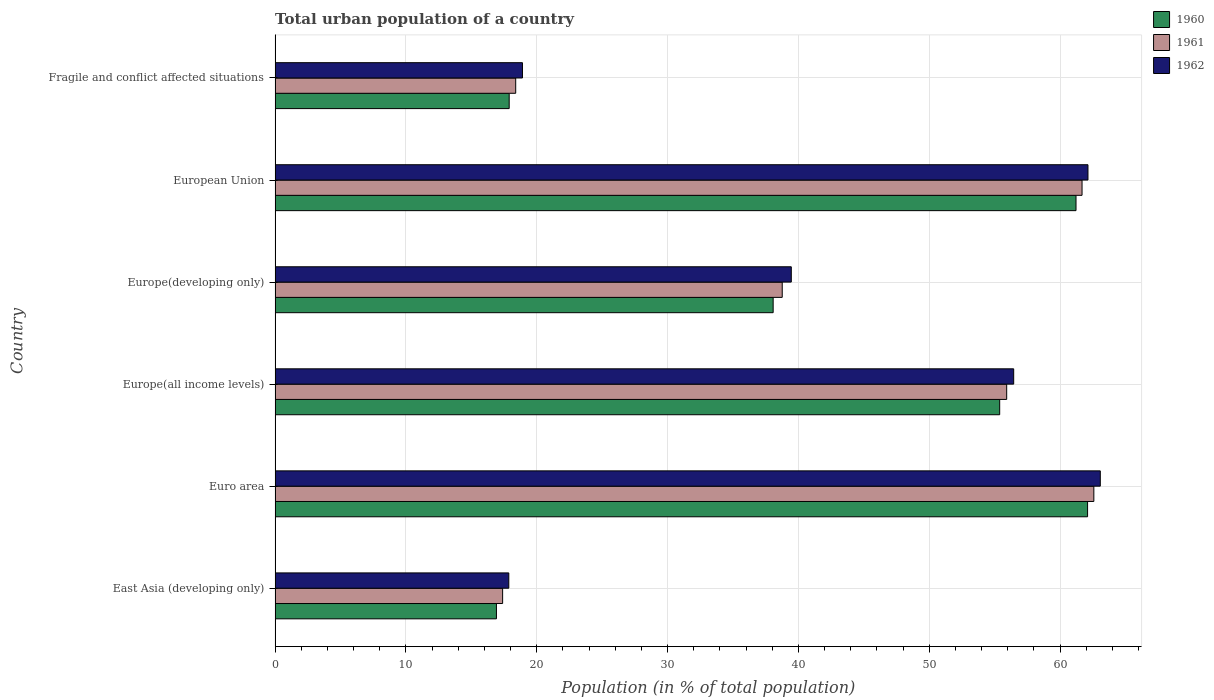How many different coloured bars are there?
Your response must be concise. 3. How many groups of bars are there?
Offer a terse response. 6. Are the number of bars on each tick of the Y-axis equal?
Your answer should be very brief. Yes. How many bars are there on the 5th tick from the top?
Offer a very short reply. 3. How many bars are there on the 5th tick from the bottom?
Your response must be concise. 3. In how many cases, is the number of bars for a given country not equal to the number of legend labels?
Offer a terse response. 0. What is the urban population in 1961 in Fragile and conflict affected situations?
Your response must be concise. 18.39. Across all countries, what is the maximum urban population in 1961?
Your answer should be compact. 62.58. Across all countries, what is the minimum urban population in 1962?
Provide a short and direct response. 17.86. In which country was the urban population in 1960 maximum?
Provide a succinct answer. Euro area. In which country was the urban population in 1960 minimum?
Give a very brief answer. East Asia (developing only). What is the total urban population in 1962 in the graph?
Your answer should be compact. 257.87. What is the difference between the urban population in 1961 in East Asia (developing only) and that in European Union?
Your answer should be very brief. -44.28. What is the difference between the urban population in 1960 in Euro area and the urban population in 1962 in European Union?
Ensure brevity in your answer.  -0.03. What is the average urban population in 1962 per country?
Your response must be concise. 42.98. What is the difference between the urban population in 1961 and urban population in 1960 in Europe(all income levels)?
Provide a succinct answer. 0.54. What is the ratio of the urban population in 1960 in Europe(all income levels) to that in Fragile and conflict affected situations?
Provide a short and direct response. 3.1. Is the urban population in 1962 in Europe(all income levels) less than that in Fragile and conflict affected situations?
Your answer should be very brief. No. What is the difference between the highest and the second highest urban population in 1960?
Offer a very short reply. 0.88. What is the difference between the highest and the lowest urban population in 1962?
Ensure brevity in your answer.  45.21. What does the 3rd bar from the top in Europe(all income levels) represents?
Offer a terse response. 1960. Is it the case that in every country, the sum of the urban population in 1962 and urban population in 1960 is greater than the urban population in 1961?
Your answer should be compact. Yes. Are all the bars in the graph horizontal?
Provide a short and direct response. Yes. How many countries are there in the graph?
Keep it short and to the point. 6. Does the graph contain grids?
Provide a short and direct response. Yes. Where does the legend appear in the graph?
Your answer should be very brief. Top right. How many legend labels are there?
Your answer should be compact. 3. How are the legend labels stacked?
Your answer should be compact. Vertical. What is the title of the graph?
Make the answer very short. Total urban population of a country. What is the label or title of the X-axis?
Your answer should be very brief. Population (in % of total population). What is the label or title of the Y-axis?
Offer a terse response. Country. What is the Population (in % of total population) of 1960 in East Asia (developing only)?
Your answer should be very brief. 16.92. What is the Population (in % of total population) of 1961 in East Asia (developing only)?
Your answer should be very brief. 17.39. What is the Population (in % of total population) in 1962 in East Asia (developing only)?
Your answer should be compact. 17.86. What is the Population (in % of total population) of 1960 in Euro area?
Provide a short and direct response. 62.1. What is the Population (in % of total population) of 1961 in Euro area?
Ensure brevity in your answer.  62.58. What is the Population (in % of total population) of 1962 in Euro area?
Offer a very short reply. 63.07. What is the Population (in % of total population) in 1960 in Europe(all income levels)?
Ensure brevity in your answer.  55.38. What is the Population (in % of total population) in 1961 in Europe(all income levels)?
Your response must be concise. 55.92. What is the Population (in % of total population) of 1962 in Europe(all income levels)?
Your answer should be compact. 56.45. What is the Population (in % of total population) of 1960 in Europe(developing only)?
Your response must be concise. 38.07. What is the Population (in % of total population) of 1961 in Europe(developing only)?
Make the answer very short. 38.76. What is the Population (in % of total population) of 1962 in Europe(developing only)?
Keep it short and to the point. 39.45. What is the Population (in % of total population) of 1960 in European Union?
Your response must be concise. 61.21. What is the Population (in % of total population) in 1961 in European Union?
Offer a terse response. 61.67. What is the Population (in % of total population) of 1962 in European Union?
Ensure brevity in your answer.  62.13. What is the Population (in % of total population) of 1960 in Fragile and conflict affected situations?
Your response must be concise. 17.89. What is the Population (in % of total population) of 1961 in Fragile and conflict affected situations?
Keep it short and to the point. 18.39. What is the Population (in % of total population) of 1962 in Fragile and conflict affected situations?
Your response must be concise. 18.91. Across all countries, what is the maximum Population (in % of total population) in 1960?
Your answer should be compact. 62.1. Across all countries, what is the maximum Population (in % of total population) in 1961?
Provide a succinct answer. 62.58. Across all countries, what is the maximum Population (in % of total population) in 1962?
Offer a terse response. 63.07. Across all countries, what is the minimum Population (in % of total population) of 1960?
Make the answer very short. 16.92. Across all countries, what is the minimum Population (in % of total population) in 1961?
Your answer should be very brief. 17.39. Across all countries, what is the minimum Population (in % of total population) of 1962?
Provide a short and direct response. 17.86. What is the total Population (in % of total population) in 1960 in the graph?
Make the answer very short. 251.56. What is the total Population (in % of total population) in 1961 in the graph?
Make the answer very short. 254.7. What is the total Population (in % of total population) of 1962 in the graph?
Your response must be concise. 257.87. What is the difference between the Population (in % of total population) in 1960 in East Asia (developing only) and that in Euro area?
Give a very brief answer. -45.18. What is the difference between the Population (in % of total population) in 1961 in East Asia (developing only) and that in Euro area?
Your answer should be very brief. -45.18. What is the difference between the Population (in % of total population) in 1962 in East Asia (developing only) and that in Euro area?
Offer a very short reply. -45.21. What is the difference between the Population (in % of total population) in 1960 in East Asia (developing only) and that in Europe(all income levels)?
Offer a very short reply. -38.46. What is the difference between the Population (in % of total population) in 1961 in East Asia (developing only) and that in Europe(all income levels)?
Your answer should be very brief. -38.52. What is the difference between the Population (in % of total population) in 1962 in East Asia (developing only) and that in Europe(all income levels)?
Your response must be concise. -38.59. What is the difference between the Population (in % of total population) in 1960 in East Asia (developing only) and that in Europe(developing only)?
Offer a very short reply. -21.15. What is the difference between the Population (in % of total population) of 1961 in East Asia (developing only) and that in Europe(developing only)?
Provide a short and direct response. -21.37. What is the difference between the Population (in % of total population) of 1962 in East Asia (developing only) and that in Europe(developing only)?
Keep it short and to the point. -21.59. What is the difference between the Population (in % of total population) in 1960 in East Asia (developing only) and that in European Union?
Provide a succinct answer. -44.3. What is the difference between the Population (in % of total population) of 1961 in East Asia (developing only) and that in European Union?
Offer a very short reply. -44.28. What is the difference between the Population (in % of total population) in 1962 in East Asia (developing only) and that in European Union?
Your answer should be very brief. -44.26. What is the difference between the Population (in % of total population) in 1960 in East Asia (developing only) and that in Fragile and conflict affected situations?
Keep it short and to the point. -0.97. What is the difference between the Population (in % of total population) of 1961 in East Asia (developing only) and that in Fragile and conflict affected situations?
Ensure brevity in your answer.  -1. What is the difference between the Population (in % of total population) of 1962 in East Asia (developing only) and that in Fragile and conflict affected situations?
Your answer should be very brief. -1.04. What is the difference between the Population (in % of total population) in 1960 in Euro area and that in Europe(all income levels)?
Give a very brief answer. 6.72. What is the difference between the Population (in % of total population) in 1961 in Euro area and that in Europe(all income levels)?
Your answer should be compact. 6.66. What is the difference between the Population (in % of total population) of 1962 in Euro area and that in Europe(all income levels)?
Offer a terse response. 6.62. What is the difference between the Population (in % of total population) in 1960 in Euro area and that in Europe(developing only)?
Your response must be concise. 24.03. What is the difference between the Population (in % of total population) of 1961 in Euro area and that in Europe(developing only)?
Provide a succinct answer. 23.82. What is the difference between the Population (in % of total population) in 1962 in Euro area and that in Europe(developing only)?
Offer a very short reply. 23.62. What is the difference between the Population (in % of total population) in 1960 in Euro area and that in European Union?
Ensure brevity in your answer.  0.88. What is the difference between the Population (in % of total population) of 1961 in Euro area and that in European Union?
Provide a short and direct response. 0.9. What is the difference between the Population (in % of total population) of 1962 in Euro area and that in European Union?
Ensure brevity in your answer.  0.94. What is the difference between the Population (in % of total population) of 1960 in Euro area and that in Fragile and conflict affected situations?
Provide a short and direct response. 44.2. What is the difference between the Population (in % of total population) in 1961 in Euro area and that in Fragile and conflict affected situations?
Your answer should be very brief. 44.19. What is the difference between the Population (in % of total population) of 1962 in Euro area and that in Fragile and conflict affected situations?
Give a very brief answer. 44.16. What is the difference between the Population (in % of total population) of 1960 in Europe(all income levels) and that in Europe(developing only)?
Your answer should be compact. 17.31. What is the difference between the Population (in % of total population) of 1961 in Europe(all income levels) and that in Europe(developing only)?
Your response must be concise. 17.16. What is the difference between the Population (in % of total population) in 1962 in Europe(all income levels) and that in Europe(developing only)?
Your answer should be very brief. 17. What is the difference between the Population (in % of total population) of 1960 in Europe(all income levels) and that in European Union?
Your response must be concise. -5.83. What is the difference between the Population (in % of total population) in 1961 in Europe(all income levels) and that in European Union?
Offer a very short reply. -5.76. What is the difference between the Population (in % of total population) of 1962 in Europe(all income levels) and that in European Union?
Provide a succinct answer. -5.68. What is the difference between the Population (in % of total population) of 1960 in Europe(all income levels) and that in Fragile and conflict affected situations?
Give a very brief answer. 37.49. What is the difference between the Population (in % of total population) in 1961 in Europe(all income levels) and that in Fragile and conflict affected situations?
Your response must be concise. 37.53. What is the difference between the Population (in % of total population) in 1962 in Europe(all income levels) and that in Fragile and conflict affected situations?
Offer a very short reply. 37.54. What is the difference between the Population (in % of total population) of 1960 in Europe(developing only) and that in European Union?
Your answer should be very brief. -23.15. What is the difference between the Population (in % of total population) of 1961 in Europe(developing only) and that in European Union?
Your answer should be very brief. -22.91. What is the difference between the Population (in % of total population) of 1962 in Europe(developing only) and that in European Union?
Make the answer very short. -22.67. What is the difference between the Population (in % of total population) of 1960 in Europe(developing only) and that in Fragile and conflict affected situations?
Your answer should be very brief. 20.17. What is the difference between the Population (in % of total population) of 1961 in Europe(developing only) and that in Fragile and conflict affected situations?
Give a very brief answer. 20.37. What is the difference between the Population (in % of total population) in 1962 in Europe(developing only) and that in Fragile and conflict affected situations?
Offer a terse response. 20.55. What is the difference between the Population (in % of total population) of 1960 in European Union and that in Fragile and conflict affected situations?
Offer a very short reply. 43.32. What is the difference between the Population (in % of total population) in 1961 in European Union and that in Fragile and conflict affected situations?
Your answer should be very brief. 43.28. What is the difference between the Population (in % of total population) of 1962 in European Union and that in Fragile and conflict affected situations?
Provide a short and direct response. 43.22. What is the difference between the Population (in % of total population) of 1960 in East Asia (developing only) and the Population (in % of total population) of 1961 in Euro area?
Offer a terse response. -45.66. What is the difference between the Population (in % of total population) of 1960 in East Asia (developing only) and the Population (in % of total population) of 1962 in Euro area?
Keep it short and to the point. -46.15. What is the difference between the Population (in % of total population) in 1961 in East Asia (developing only) and the Population (in % of total population) in 1962 in Euro area?
Your answer should be compact. -45.68. What is the difference between the Population (in % of total population) in 1960 in East Asia (developing only) and the Population (in % of total population) in 1961 in Europe(all income levels)?
Make the answer very short. -39. What is the difference between the Population (in % of total population) in 1960 in East Asia (developing only) and the Population (in % of total population) in 1962 in Europe(all income levels)?
Your answer should be compact. -39.53. What is the difference between the Population (in % of total population) in 1961 in East Asia (developing only) and the Population (in % of total population) in 1962 in Europe(all income levels)?
Offer a terse response. -39.06. What is the difference between the Population (in % of total population) of 1960 in East Asia (developing only) and the Population (in % of total population) of 1961 in Europe(developing only)?
Offer a terse response. -21.84. What is the difference between the Population (in % of total population) of 1960 in East Asia (developing only) and the Population (in % of total population) of 1962 in Europe(developing only)?
Your answer should be compact. -22.54. What is the difference between the Population (in % of total population) in 1961 in East Asia (developing only) and the Population (in % of total population) in 1962 in Europe(developing only)?
Make the answer very short. -22.06. What is the difference between the Population (in % of total population) in 1960 in East Asia (developing only) and the Population (in % of total population) in 1961 in European Union?
Offer a very short reply. -44.76. What is the difference between the Population (in % of total population) of 1960 in East Asia (developing only) and the Population (in % of total population) of 1962 in European Union?
Provide a succinct answer. -45.21. What is the difference between the Population (in % of total population) of 1961 in East Asia (developing only) and the Population (in % of total population) of 1962 in European Union?
Make the answer very short. -44.74. What is the difference between the Population (in % of total population) of 1960 in East Asia (developing only) and the Population (in % of total population) of 1961 in Fragile and conflict affected situations?
Provide a short and direct response. -1.47. What is the difference between the Population (in % of total population) of 1960 in East Asia (developing only) and the Population (in % of total population) of 1962 in Fragile and conflict affected situations?
Offer a terse response. -1.99. What is the difference between the Population (in % of total population) in 1961 in East Asia (developing only) and the Population (in % of total population) in 1962 in Fragile and conflict affected situations?
Provide a succinct answer. -1.52. What is the difference between the Population (in % of total population) of 1960 in Euro area and the Population (in % of total population) of 1961 in Europe(all income levels)?
Make the answer very short. 6.18. What is the difference between the Population (in % of total population) in 1960 in Euro area and the Population (in % of total population) in 1962 in Europe(all income levels)?
Your response must be concise. 5.65. What is the difference between the Population (in % of total population) in 1961 in Euro area and the Population (in % of total population) in 1962 in Europe(all income levels)?
Ensure brevity in your answer.  6.13. What is the difference between the Population (in % of total population) in 1960 in Euro area and the Population (in % of total population) in 1961 in Europe(developing only)?
Your answer should be very brief. 23.34. What is the difference between the Population (in % of total population) in 1960 in Euro area and the Population (in % of total population) in 1962 in Europe(developing only)?
Ensure brevity in your answer.  22.64. What is the difference between the Population (in % of total population) of 1961 in Euro area and the Population (in % of total population) of 1962 in Europe(developing only)?
Give a very brief answer. 23.12. What is the difference between the Population (in % of total population) in 1960 in Euro area and the Population (in % of total population) in 1961 in European Union?
Make the answer very short. 0.42. What is the difference between the Population (in % of total population) in 1960 in Euro area and the Population (in % of total population) in 1962 in European Union?
Your response must be concise. -0.03. What is the difference between the Population (in % of total population) of 1961 in Euro area and the Population (in % of total population) of 1962 in European Union?
Your answer should be very brief. 0.45. What is the difference between the Population (in % of total population) in 1960 in Euro area and the Population (in % of total population) in 1961 in Fragile and conflict affected situations?
Make the answer very short. 43.71. What is the difference between the Population (in % of total population) of 1960 in Euro area and the Population (in % of total population) of 1962 in Fragile and conflict affected situations?
Your answer should be very brief. 43.19. What is the difference between the Population (in % of total population) in 1961 in Euro area and the Population (in % of total population) in 1962 in Fragile and conflict affected situations?
Your answer should be very brief. 43.67. What is the difference between the Population (in % of total population) in 1960 in Europe(all income levels) and the Population (in % of total population) in 1961 in Europe(developing only)?
Ensure brevity in your answer.  16.62. What is the difference between the Population (in % of total population) of 1960 in Europe(all income levels) and the Population (in % of total population) of 1962 in Europe(developing only)?
Ensure brevity in your answer.  15.93. What is the difference between the Population (in % of total population) of 1961 in Europe(all income levels) and the Population (in % of total population) of 1962 in Europe(developing only)?
Ensure brevity in your answer.  16.46. What is the difference between the Population (in % of total population) in 1960 in Europe(all income levels) and the Population (in % of total population) in 1961 in European Union?
Give a very brief answer. -6.29. What is the difference between the Population (in % of total population) in 1960 in Europe(all income levels) and the Population (in % of total population) in 1962 in European Union?
Provide a short and direct response. -6.75. What is the difference between the Population (in % of total population) of 1961 in Europe(all income levels) and the Population (in % of total population) of 1962 in European Union?
Ensure brevity in your answer.  -6.21. What is the difference between the Population (in % of total population) in 1960 in Europe(all income levels) and the Population (in % of total population) in 1961 in Fragile and conflict affected situations?
Make the answer very short. 36.99. What is the difference between the Population (in % of total population) of 1960 in Europe(all income levels) and the Population (in % of total population) of 1962 in Fragile and conflict affected situations?
Your answer should be compact. 36.47. What is the difference between the Population (in % of total population) in 1961 in Europe(all income levels) and the Population (in % of total population) in 1962 in Fragile and conflict affected situations?
Make the answer very short. 37.01. What is the difference between the Population (in % of total population) in 1960 in Europe(developing only) and the Population (in % of total population) in 1961 in European Union?
Make the answer very short. -23.61. What is the difference between the Population (in % of total population) of 1960 in Europe(developing only) and the Population (in % of total population) of 1962 in European Union?
Give a very brief answer. -24.06. What is the difference between the Population (in % of total population) of 1961 in Europe(developing only) and the Population (in % of total population) of 1962 in European Union?
Provide a succinct answer. -23.37. What is the difference between the Population (in % of total population) in 1960 in Europe(developing only) and the Population (in % of total population) in 1961 in Fragile and conflict affected situations?
Give a very brief answer. 19.68. What is the difference between the Population (in % of total population) of 1960 in Europe(developing only) and the Population (in % of total population) of 1962 in Fragile and conflict affected situations?
Make the answer very short. 19.16. What is the difference between the Population (in % of total population) in 1961 in Europe(developing only) and the Population (in % of total population) in 1962 in Fragile and conflict affected situations?
Provide a succinct answer. 19.85. What is the difference between the Population (in % of total population) in 1960 in European Union and the Population (in % of total population) in 1961 in Fragile and conflict affected situations?
Offer a terse response. 42.82. What is the difference between the Population (in % of total population) of 1960 in European Union and the Population (in % of total population) of 1962 in Fragile and conflict affected situations?
Provide a succinct answer. 42.31. What is the difference between the Population (in % of total population) in 1961 in European Union and the Population (in % of total population) in 1962 in Fragile and conflict affected situations?
Give a very brief answer. 42.77. What is the average Population (in % of total population) in 1960 per country?
Provide a short and direct response. 41.93. What is the average Population (in % of total population) of 1961 per country?
Keep it short and to the point. 42.45. What is the average Population (in % of total population) in 1962 per country?
Your answer should be very brief. 42.98. What is the difference between the Population (in % of total population) in 1960 and Population (in % of total population) in 1961 in East Asia (developing only)?
Your answer should be very brief. -0.47. What is the difference between the Population (in % of total population) of 1960 and Population (in % of total population) of 1962 in East Asia (developing only)?
Your answer should be compact. -0.95. What is the difference between the Population (in % of total population) of 1961 and Population (in % of total population) of 1962 in East Asia (developing only)?
Your answer should be compact. -0.47. What is the difference between the Population (in % of total population) in 1960 and Population (in % of total population) in 1961 in Euro area?
Provide a succinct answer. -0.48. What is the difference between the Population (in % of total population) of 1960 and Population (in % of total population) of 1962 in Euro area?
Your answer should be compact. -0.97. What is the difference between the Population (in % of total population) in 1961 and Population (in % of total population) in 1962 in Euro area?
Your response must be concise. -0.49. What is the difference between the Population (in % of total population) in 1960 and Population (in % of total population) in 1961 in Europe(all income levels)?
Offer a terse response. -0.54. What is the difference between the Population (in % of total population) in 1960 and Population (in % of total population) in 1962 in Europe(all income levels)?
Ensure brevity in your answer.  -1.07. What is the difference between the Population (in % of total population) of 1961 and Population (in % of total population) of 1962 in Europe(all income levels)?
Ensure brevity in your answer.  -0.53. What is the difference between the Population (in % of total population) in 1960 and Population (in % of total population) in 1961 in Europe(developing only)?
Provide a short and direct response. -0.69. What is the difference between the Population (in % of total population) of 1960 and Population (in % of total population) of 1962 in Europe(developing only)?
Give a very brief answer. -1.39. What is the difference between the Population (in % of total population) of 1961 and Population (in % of total population) of 1962 in Europe(developing only)?
Offer a terse response. -0.69. What is the difference between the Population (in % of total population) in 1960 and Population (in % of total population) in 1961 in European Union?
Your answer should be very brief. -0.46. What is the difference between the Population (in % of total population) in 1960 and Population (in % of total population) in 1962 in European Union?
Your answer should be compact. -0.91. What is the difference between the Population (in % of total population) in 1961 and Population (in % of total population) in 1962 in European Union?
Provide a succinct answer. -0.45. What is the difference between the Population (in % of total population) in 1960 and Population (in % of total population) in 1961 in Fragile and conflict affected situations?
Offer a terse response. -0.5. What is the difference between the Population (in % of total population) of 1960 and Population (in % of total population) of 1962 in Fragile and conflict affected situations?
Offer a very short reply. -1.02. What is the difference between the Population (in % of total population) of 1961 and Population (in % of total population) of 1962 in Fragile and conflict affected situations?
Your response must be concise. -0.52. What is the ratio of the Population (in % of total population) of 1960 in East Asia (developing only) to that in Euro area?
Provide a succinct answer. 0.27. What is the ratio of the Population (in % of total population) in 1961 in East Asia (developing only) to that in Euro area?
Keep it short and to the point. 0.28. What is the ratio of the Population (in % of total population) of 1962 in East Asia (developing only) to that in Euro area?
Make the answer very short. 0.28. What is the ratio of the Population (in % of total population) in 1960 in East Asia (developing only) to that in Europe(all income levels)?
Offer a very short reply. 0.31. What is the ratio of the Population (in % of total population) of 1961 in East Asia (developing only) to that in Europe(all income levels)?
Your response must be concise. 0.31. What is the ratio of the Population (in % of total population) in 1962 in East Asia (developing only) to that in Europe(all income levels)?
Provide a short and direct response. 0.32. What is the ratio of the Population (in % of total population) in 1960 in East Asia (developing only) to that in Europe(developing only)?
Provide a short and direct response. 0.44. What is the ratio of the Population (in % of total population) of 1961 in East Asia (developing only) to that in Europe(developing only)?
Make the answer very short. 0.45. What is the ratio of the Population (in % of total population) in 1962 in East Asia (developing only) to that in Europe(developing only)?
Provide a succinct answer. 0.45. What is the ratio of the Population (in % of total population) in 1960 in East Asia (developing only) to that in European Union?
Offer a very short reply. 0.28. What is the ratio of the Population (in % of total population) in 1961 in East Asia (developing only) to that in European Union?
Offer a terse response. 0.28. What is the ratio of the Population (in % of total population) of 1962 in East Asia (developing only) to that in European Union?
Provide a succinct answer. 0.29. What is the ratio of the Population (in % of total population) of 1960 in East Asia (developing only) to that in Fragile and conflict affected situations?
Offer a very short reply. 0.95. What is the ratio of the Population (in % of total population) in 1961 in East Asia (developing only) to that in Fragile and conflict affected situations?
Offer a terse response. 0.95. What is the ratio of the Population (in % of total population) of 1962 in East Asia (developing only) to that in Fragile and conflict affected situations?
Your answer should be compact. 0.94. What is the ratio of the Population (in % of total population) in 1960 in Euro area to that in Europe(all income levels)?
Offer a terse response. 1.12. What is the ratio of the Population (in % of total population) of 1961 in Euro area to that in Europe(all income levels)?
Your answer should be compact. 1.12. What is the ratio of the Population (in % of total population) of 1962 in Euro area to that in Europe(all income levels)?
Your answer should be compact. 1.12. What is the ratio of the Population (in % of total population) of 1960 in Euro area to that in Europe(developing only)?
Keep it short and to the point. 1.63. What is the ratio of the Population (in % of total population) in 1961 in Euro area to that in Europe(developing only)?
Provide a succinct answer. 1.61. What is the ratio of the Population (in % of total population) of 1962 in Euro area to that in Europe(developing only)?
Your response must be concise. 1.6. What is the ratio of the Population (in % of total population) of 1960 in Euro area to that in European Union?
Your response must be concise. 1.01. What is the ratio of the Population (in % of total population) of 1961 in Euro area to that in European Union?
Your response must be concise. 1.01. What is the ratio of the Population (in % of total population) in 1962 in Euro area to that in European Union?
Keep it short and to the point. 1.02. What is the ratio of the Population (in % of total population) in 1960 in Euro area to that in Fragile and conflict affected situations?
Provide a succinct answer. 3.47. What is the ratio of the Population (in % of total population) of 1961 in Euro area to that in Fragile and conflict affected situations?
Provide a short and direct response. 3.4. What is the ratio of the Population (in % of total population) of 1962 in Euro area to that in Fragile and conflict affected situations?
Offer a very short reply. 3.34. What is the ratio of the Population (in % of total population) in 1960 in Europe(all income levels) to that in Europe(developing only)?
Provide a short and direct response. 1.45. What is the ratio of the Population (in % of total population) of 1961 in Europe(all income levels) to that in Europe(developing only)?
Make the answer very short. 1.44. What is the ratio of the Population (in % of total population) in 1962 in Europe(all income levels) to that in Europe(developing only)?
Offer a very short reply. 1.43. What is the ratio of the Population (in % of total population) of 1960 in Europe(all income levels) to that in European Union?
Your response must be concise. 0.9. What is the ratio of the Population (in % of total population) in 1961 in Europe(all income levels) to that in European Union?
Offer a terse response. 0.91. What is the ratio of the Population (in % of total population) of 1962 in Europe(all income levels) to that in European Union?
Your response must be concise. 0.91. What is the ratio of the Population (in % of total population) in 1960 in Europe(all income levels) to that in Fragile and conflict affected situations?
Make the answer very short. 3.1. What is the ratio of the Population (in % of total population) of 1961 in Europe(all income levels) to that in Fragile and conflict affected situations?
Ensure brevity in your answer.  3.04. What is the ratio of the Population (in % of total population) in 1962 in Europe(all income levels) to that in Fragile and conflict affected situations?
Provide a succinct answer. 2.99. What is the ratio of the Population (in % of total population) of 1960 in Europe(developing only) to that in European Union?
Keep it short and to the point. 0.62. What is the ratio of the Population (in % of total population) of 1961 in Europe(developing only) to that in European Union?
Make the answer very short. 0.63. What is the ratio of the Population (in % of total population) of 1962 in Europe(developing only) to that in European Union?
Offer a terse response. 0.64. What is the ratio of the Population (in % of total population) of 1960 in Europe(developing only) to that in Fragile and conflict affected situations?
Ensure brevity in your answer.  2.13. What is the ratio of the Population (in % of total population) of 1961 in Europe(developing only) to that in Fragile and conflict affected situations?
Your answer should be very brief. 2.11. What is the ratio of the Population (in % of total population) of 1962 in Europe(developing only) to that in Fragile and conflict affected situations?
Ensure brevity in your answer.  2.09. What is the ratio of the Population (in % of total population) in 1960 in European Union to that in Fragile and conflict affected situations?
Your response must be concise. 3.42. What is the ratio of the Population (in % of total population) of 1961 in European Union to that in Fragile and conflict affected situations?
Provide a succinct answer. 3.35. What is the ratio of the Population (in % of total population) in 1962 in European Union to that in Fragile and conflict affected situations?
Provide a short and direct response. 3.29. What is the difference between the highest and the second highest Population (in % of total population) in 1960?
Your answer should be compact. 0.88. What is the difference between the highest and the second highest Population (in % of total population) of 1961?
Make the answer very short. 0.9. What is the difference between the highest and the second highest Population (in % of total population) in 1962?
Offer a very short reply. 0.94. What is the difference between the highest and the lowest Population (in % of total population) in 1960?
Your answer should be compact. 45.18. What is the difference between the highest and the lowest Population (in % of total population) of 1961?
Your answer should be very brief. 45.18. What is the difference between the highest and the lowest Population (in % of total population) in 1962?
Your answer should be very brief. 45.21. 